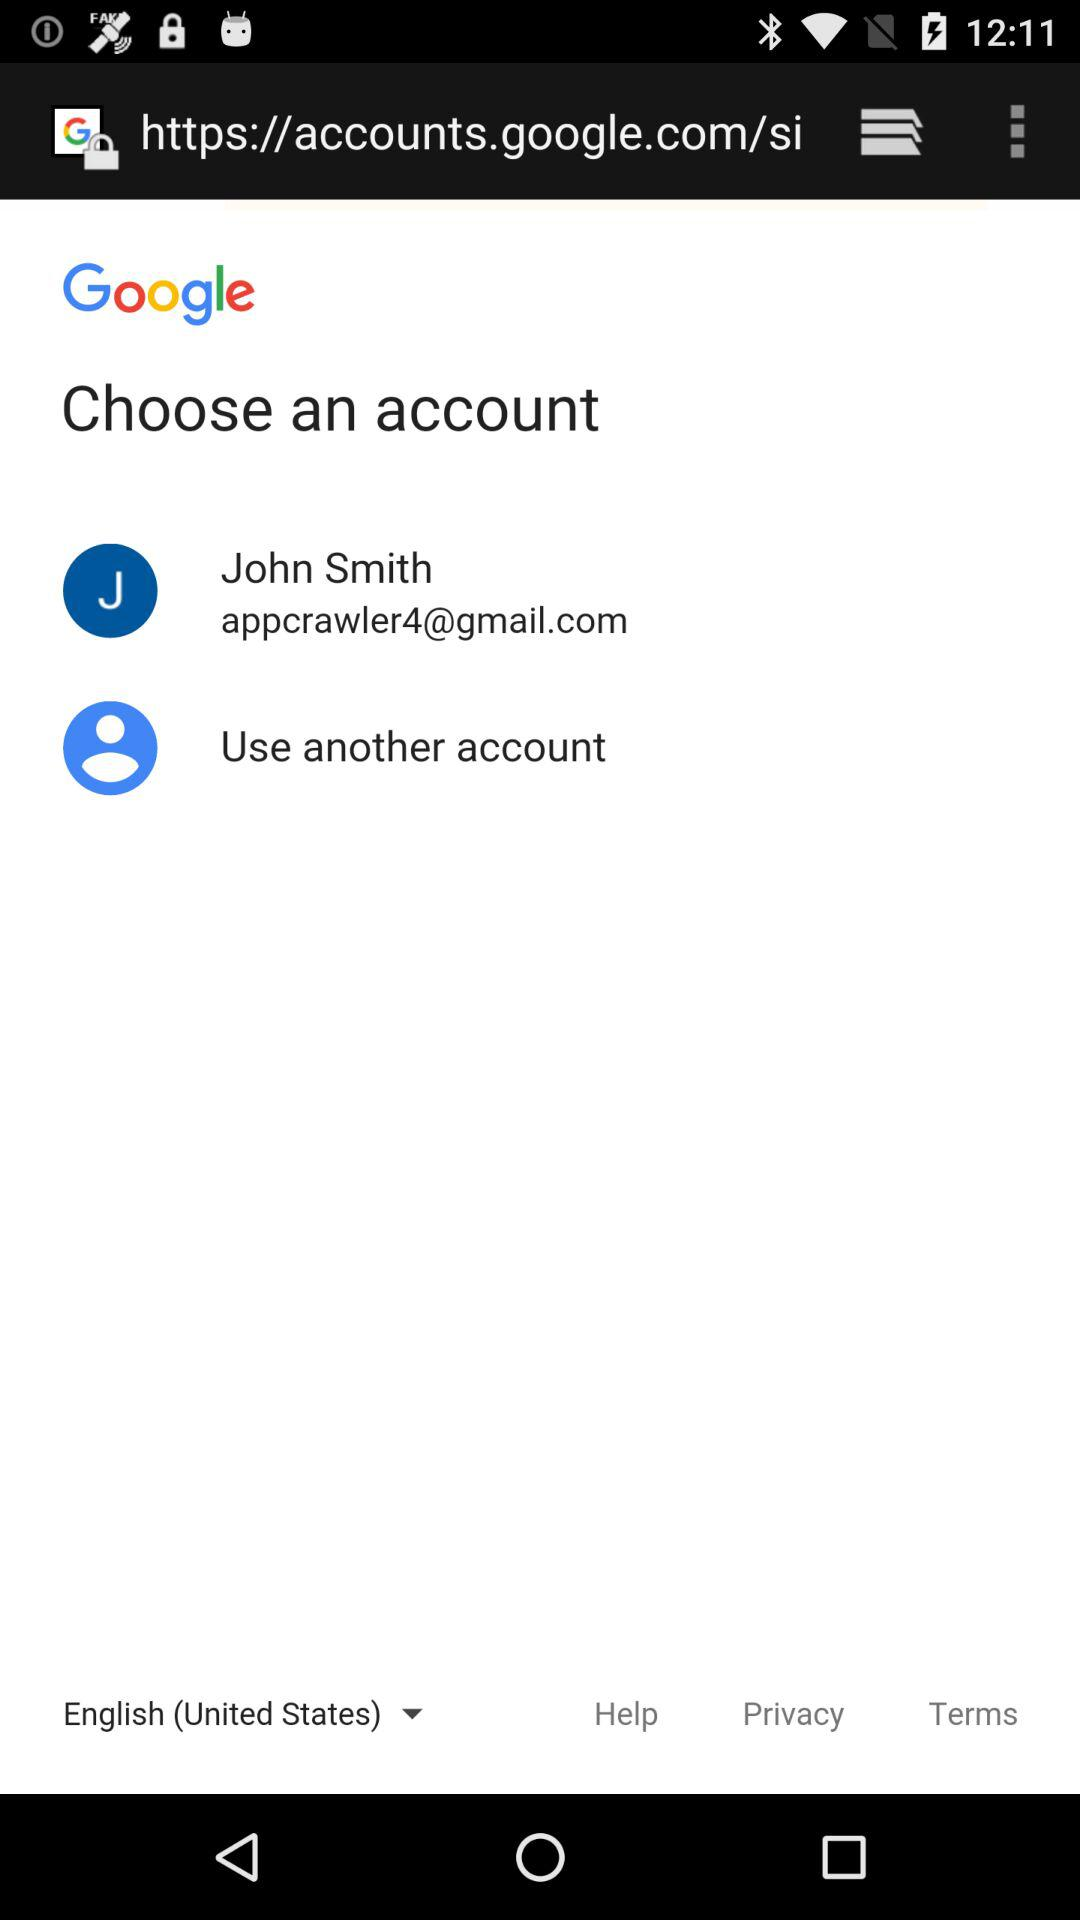What is the user name? The user name is "John Smith". 